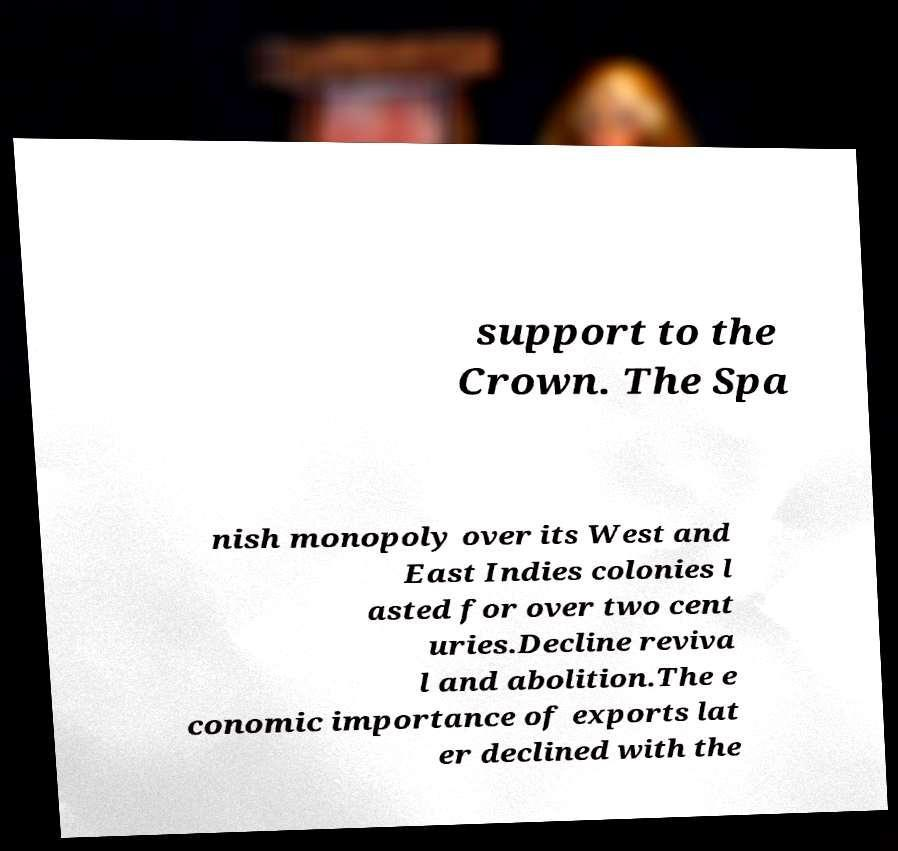What messages or text are displayed in this image? I need them in a readable, typed format. support to the Crown. The Spa nish monopoly over its West and East Indies colonies l asted for over two cent uries.Decline reviva l and abolition.The e conomic importance of exports lat er declined with the 